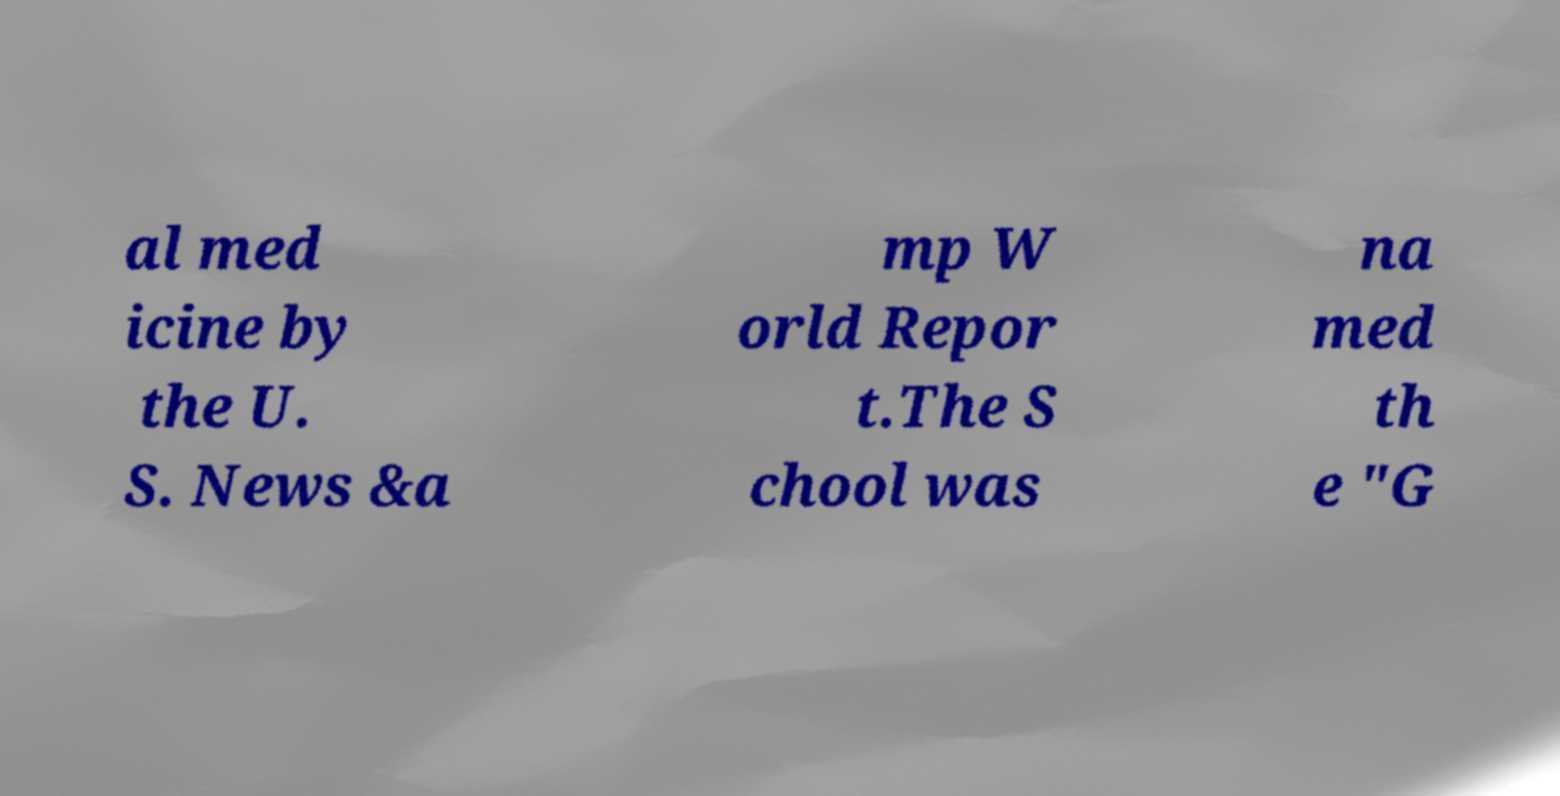Please read and relay the text visible in this image. What does it say? al med icine by the U. S. News &a mp W orld Repor t.The S chool was na med th e "G 